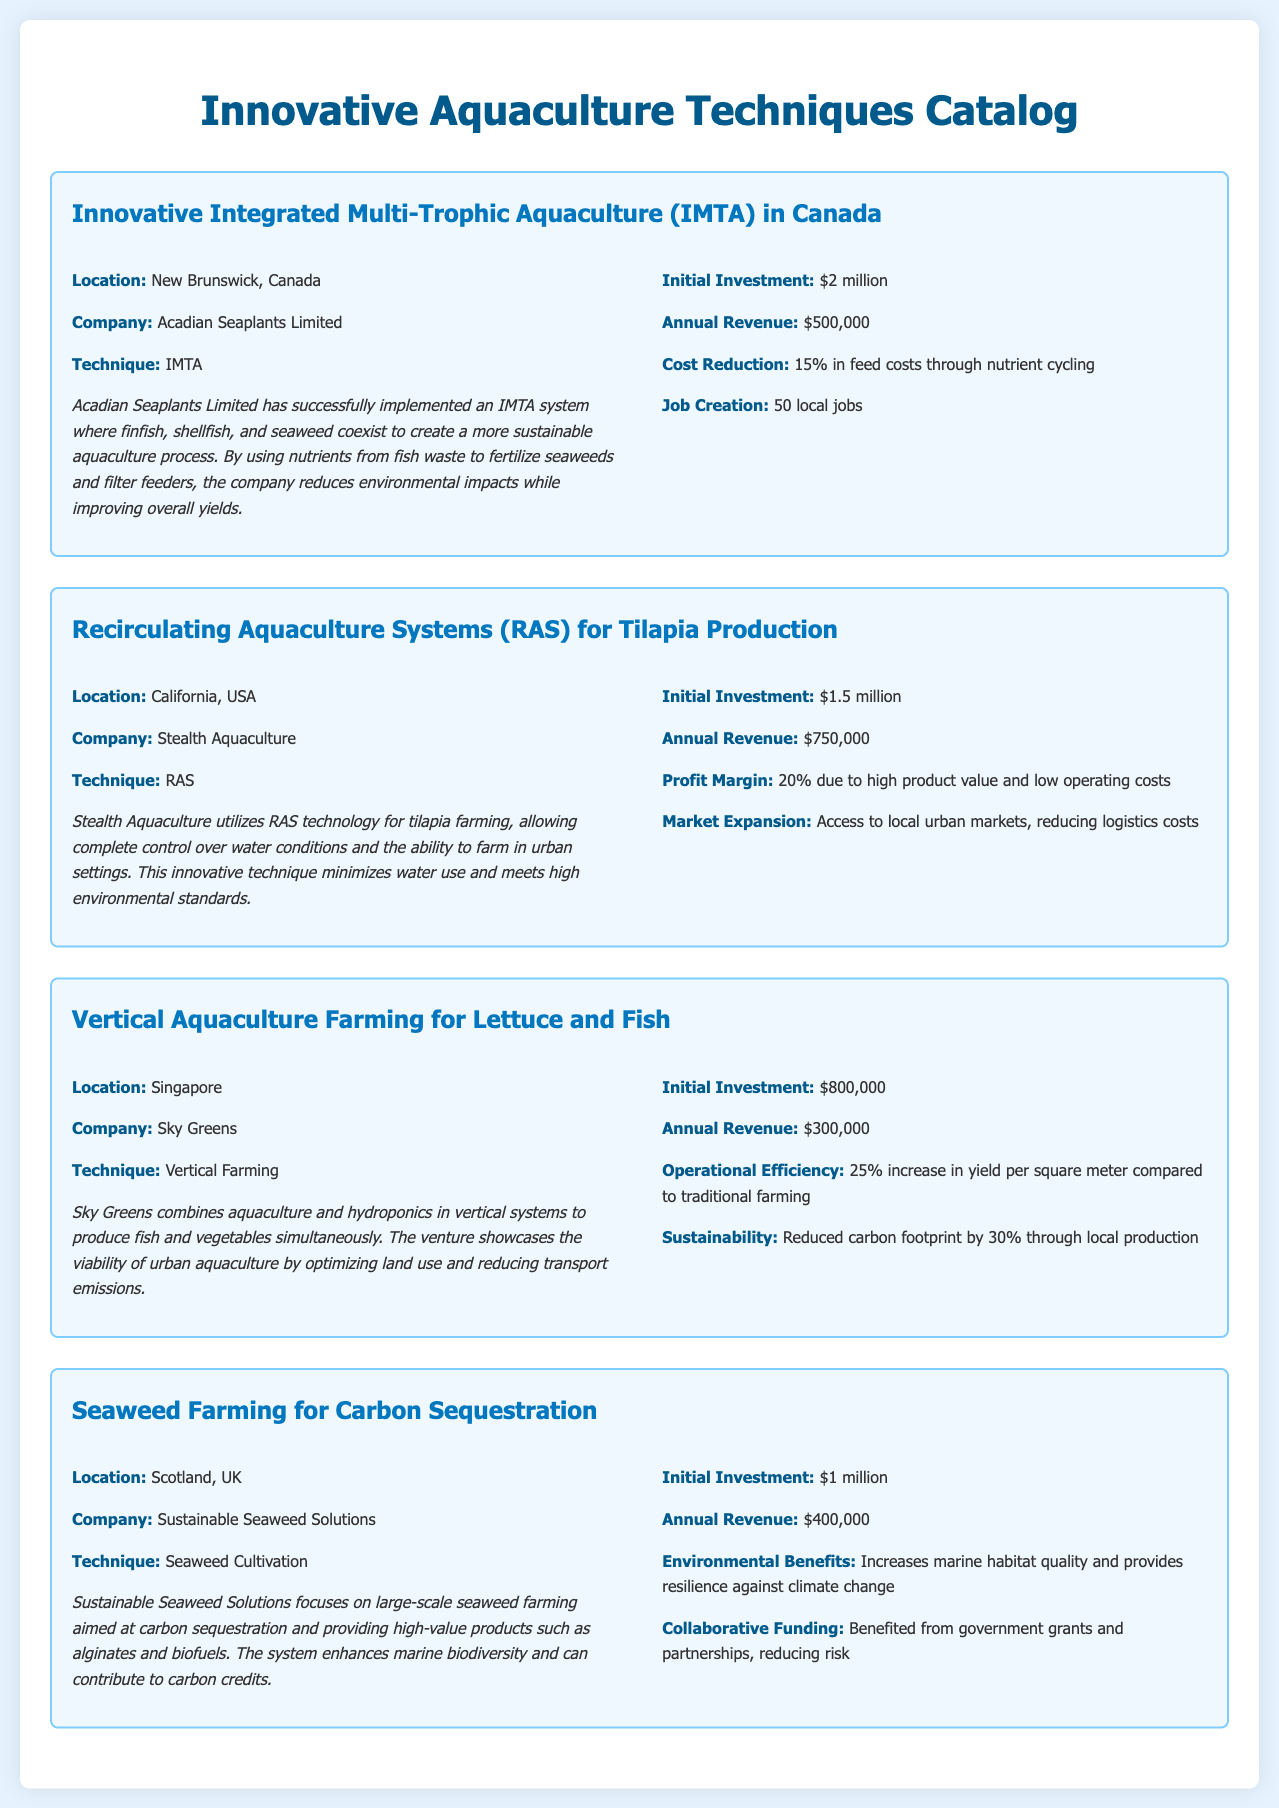What is the location of the IMTA case study? The document states that the IMTA case study is located in New Brunswick, Canada.
Answer: New Brunswick, Canada Who implemented the RAS technique? The document indicates that Stealth Aquaculture is the company that utilizes the RAS technique for tilapia production.
Answer: Stealth Aquaculture What is the annual revenue for the vertical aquaculture farming case? According to the document, the annual revenue for this case study is $300,000.
Answer: $300,000 How much was the initial investment for seaweed farming? The seaweed farming venture's initial investment is reported to be $1 million in the document.
Answer: $1 million What was the job creation from the IMTA venture? The document mentions that the IMTA venture created 50 local jobs.
Answer: 50 local jobs Which technique ensures complete control over water conditions? The document states that the RAS (Recirculating Aquaculture Systems) technique allows complete control over water conditions.
Answer: RAS How much is the profit margin for the RAS case study? The profit margin mentioned in the document for the RAS case study is 20%.
Answer: 20% What is the environmental benefit highlighted for seaweed farming? The document points out that the seaweed farming system increases marine habitat quality and resilience against climate change.
Answer: Increases marine habitat quality What percentage increase in yield does vertical aquaculture achieve? The document states that there is a 25% increase in yield per square meter compared to traditional farming.
Answer: 25% 